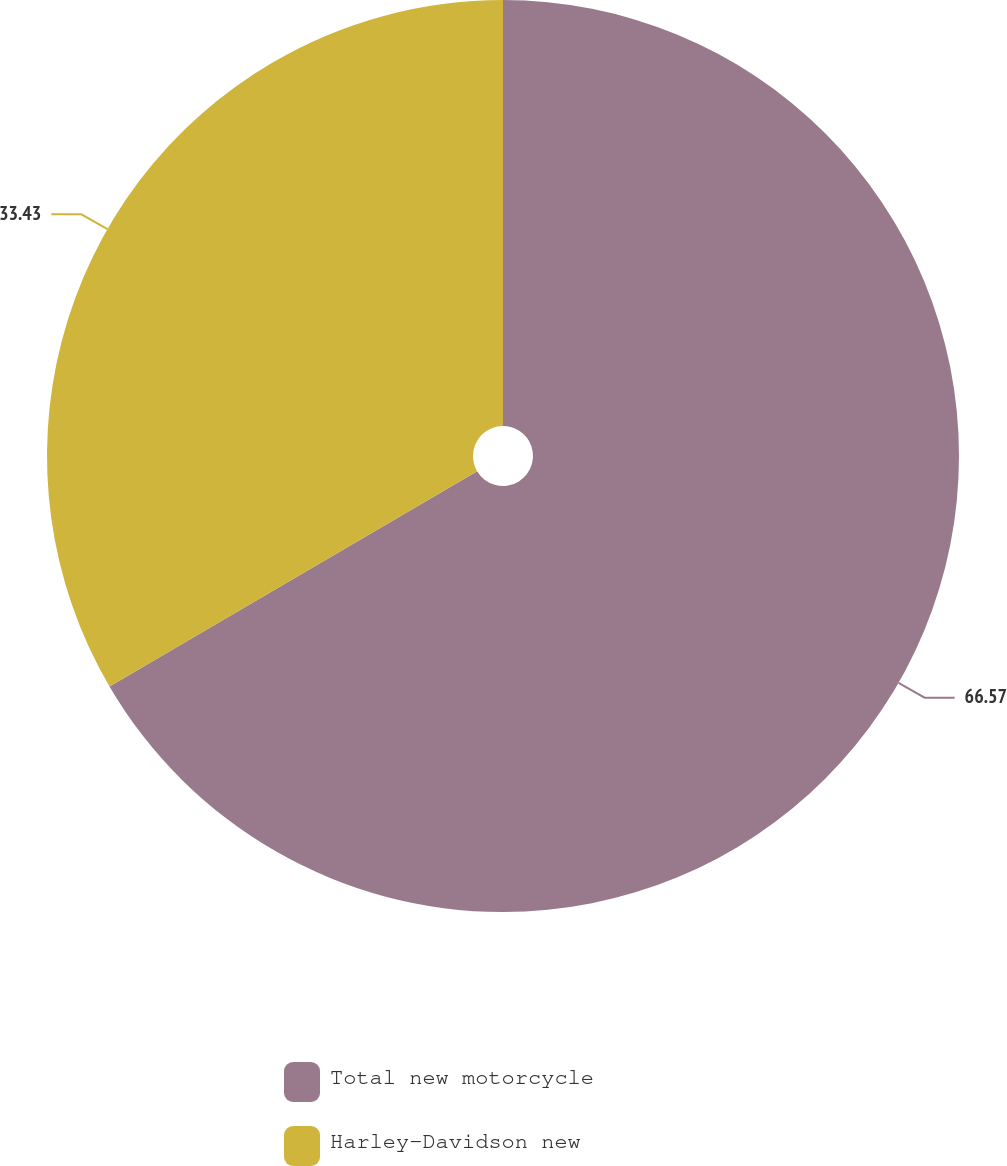Convert chart. <chart><loc_0><loc_0><loc_500><loc_500><pie_chart><fcel>Total new motorcycle<fcel>Harley-Davidson new<nl><fcel>66.57%<fcel>33.43%<nl></chart> 